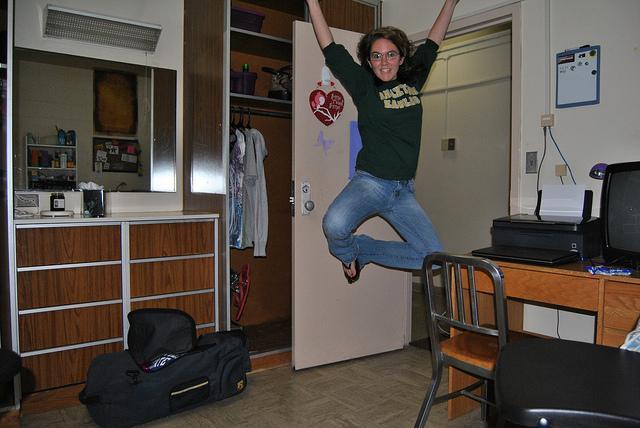How many suitcases are there?
Give a very brief answer. 1. 